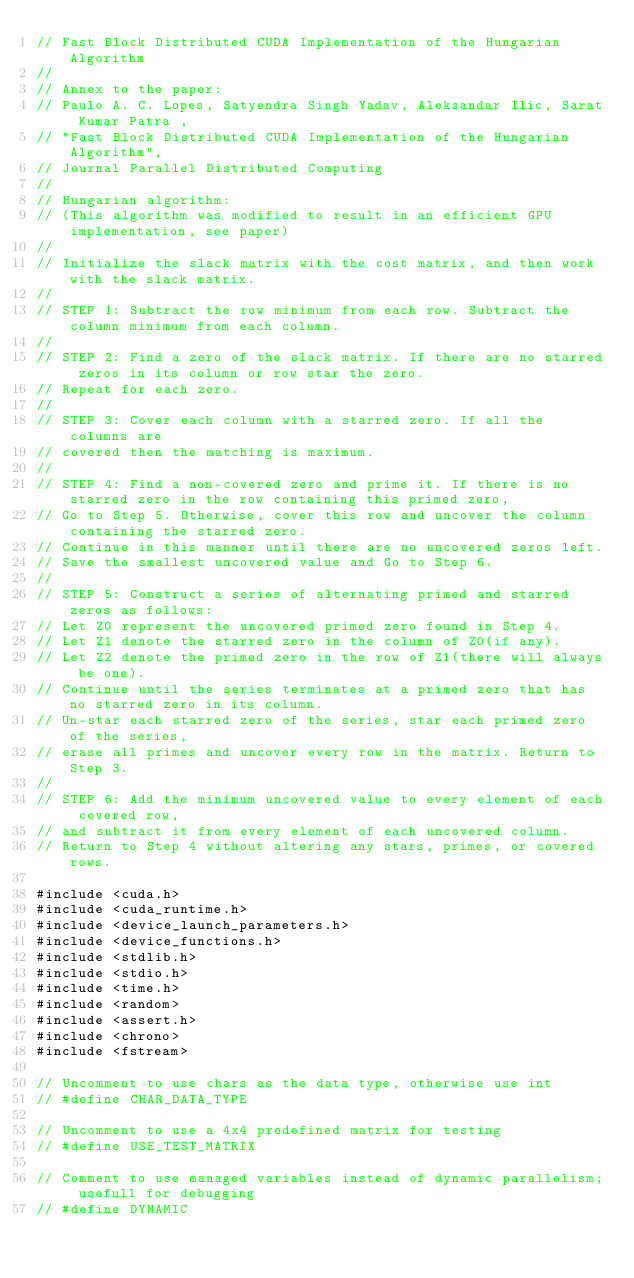<code> <loc_0><loc_0><loc_500><loc_500><_Cuda_>// Fast Block Distributed CUDA Implementation of the Hungarian Algorithm
//
// Annex to the paper:
// Paulo A. C. Lopes, Satyendra Singh Yadav, Aleksandar Ilic, Sarat Kumar Patra , 
// "Fast Block Distributed CUDA Implementation of the Hungarian Algorithm",
// Journal Parallel Distributed Computing
//
// Hungarian algorithm:
// (This algorithm was modified to result in an efficient GPU implementation, see paper)
//
// Initialize the slack matrix with the cost matrix, and then work with the slack matrix.
//
// STEP 1: Subtract the row minimum from each row. Subtract the column minimum from each column.
//
// STEP 2: Find a zero of the slack matrix. If there are no starred zeros in its column or row star the zero.
// Repeat for each zero.
//
// STEP 3: Cover each column with a starred zero. If all the columns are
// covered then the matching is maximum.
//
// STEP 4: Find a non-covered zero and prime it. If there is no starred zero in the row containing this primed zero,
// Go to Step 5. Otherwise, cover this row and uncover the column containing the starred zero.
// Continue in this manner until there are no uncovered zeros left.
// Save the smallest uncovered value and Go to Step 6.
//
// STEP 5: Construct a series of alternating primed and starred zeros as follows:
// Let Z0 represent the uncovered primed zero found in Step 4.
// Let Z1 denote the starred zero in the column of Z0(if any).
// Let Z2 denote the primed zero in the row of Z1(there will always be one).
// Continue until the series terminates at a primed zero that has no starred zero in its column.
// Un-star each starred zero of the series, star each primed zero of the series, 
// erase all primes and uncover every row in the matrix. Return to Step 3.
//
// STEP 6: Add the minimum uncovered value to every element of each covered row, 
// and subtract it from every element of each uncovered column.
// Return to Step 4 without altering any stars, primes, or covered rows.

#include <cuda.h>
#include <cuda_runtime.h>
#include <device_launch_parameters.h>
#include <device_functions.h>
#include <stdlib.h>
#include <stdio.h>
#include <time.h>
#include <random>
#include <assert.h>
#include <chrono>
#include <fstream>

// Uncomment to use chars as the data type, otherwise use int
// #define CHAR_DATA_TYPE

// Uncomment to use a 4x4 predefined matrix for testing
// #define USE_TEST_MATRIX

// Comment to use managed variables instead of dynamic parallelism; usefull for debugging
// #define DYNAMIC

</code> 